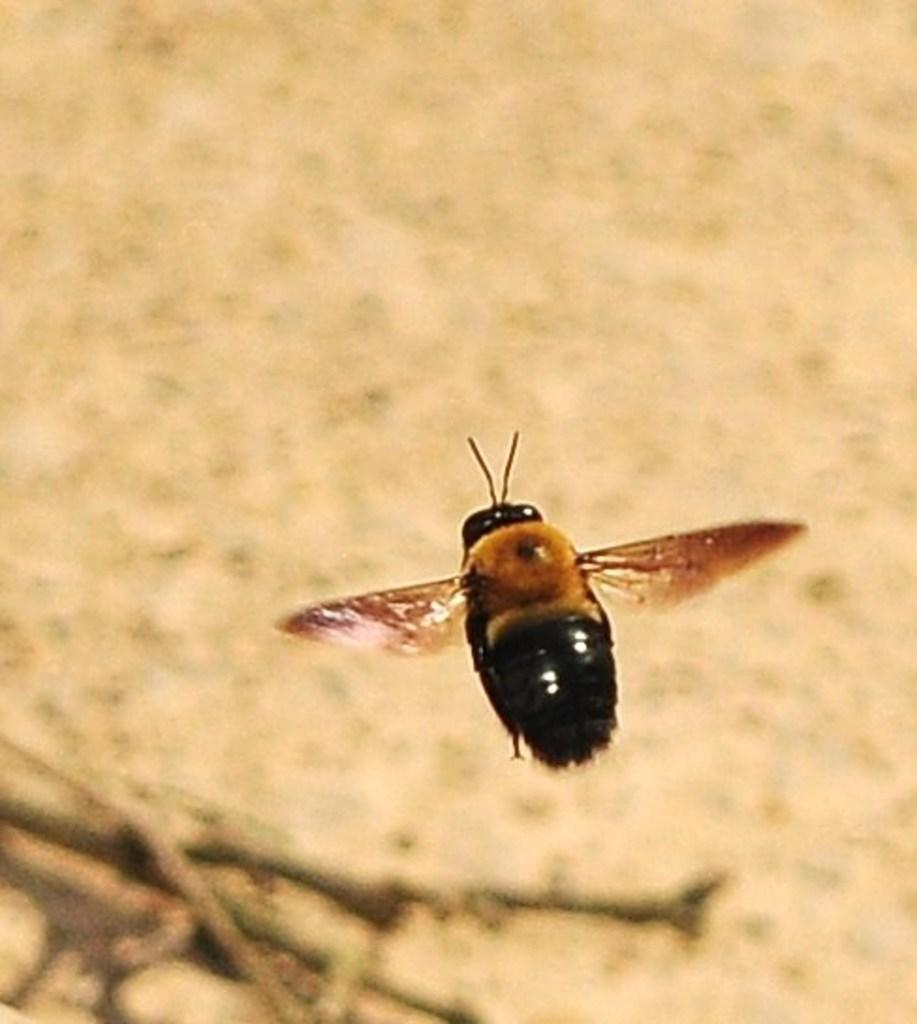What type of creature can be seen in the image? There is an insect in the image. Can you describe the background of the image? The background of the image is blurred. What type of bun is visible in the image? There is no bun present in the image. What type of rail can be seen in the image? There is no rail present in the image. 